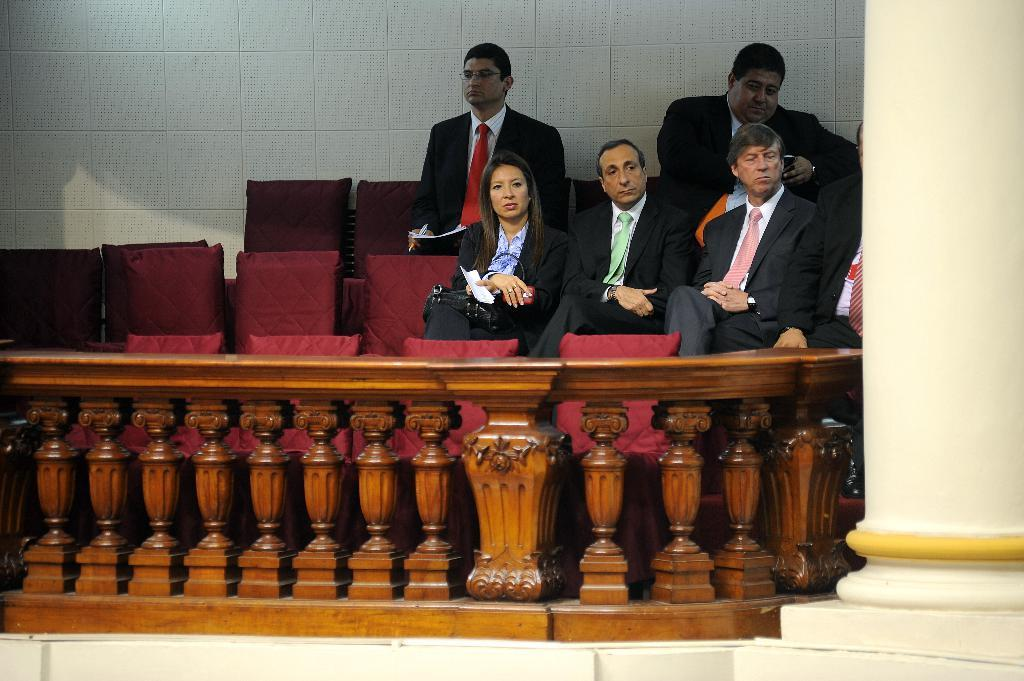What is the woman in the image doing? The woman is sitting in the image. What is the woman's facial expression or direction of gaze? The woman is looking to one side. What type of clothing is the woman wearing? The woman is wearing a coat and trousers. How many men are sitting in the image? There are four men sitting in the image. What are the men sitting on? The men are sitting on chairs. What are the men doing or observing? The men are observing something. What type of muscle is visible on the woman's arm in the image? There is no muscle visible on the woman's arm in the image. What type of suit is the woman wearing in the image? The woman is not wearing a suit in the image; she is wearing a coat and trousers. How many clams are present on the table in the image? There are no clams present in the image. 